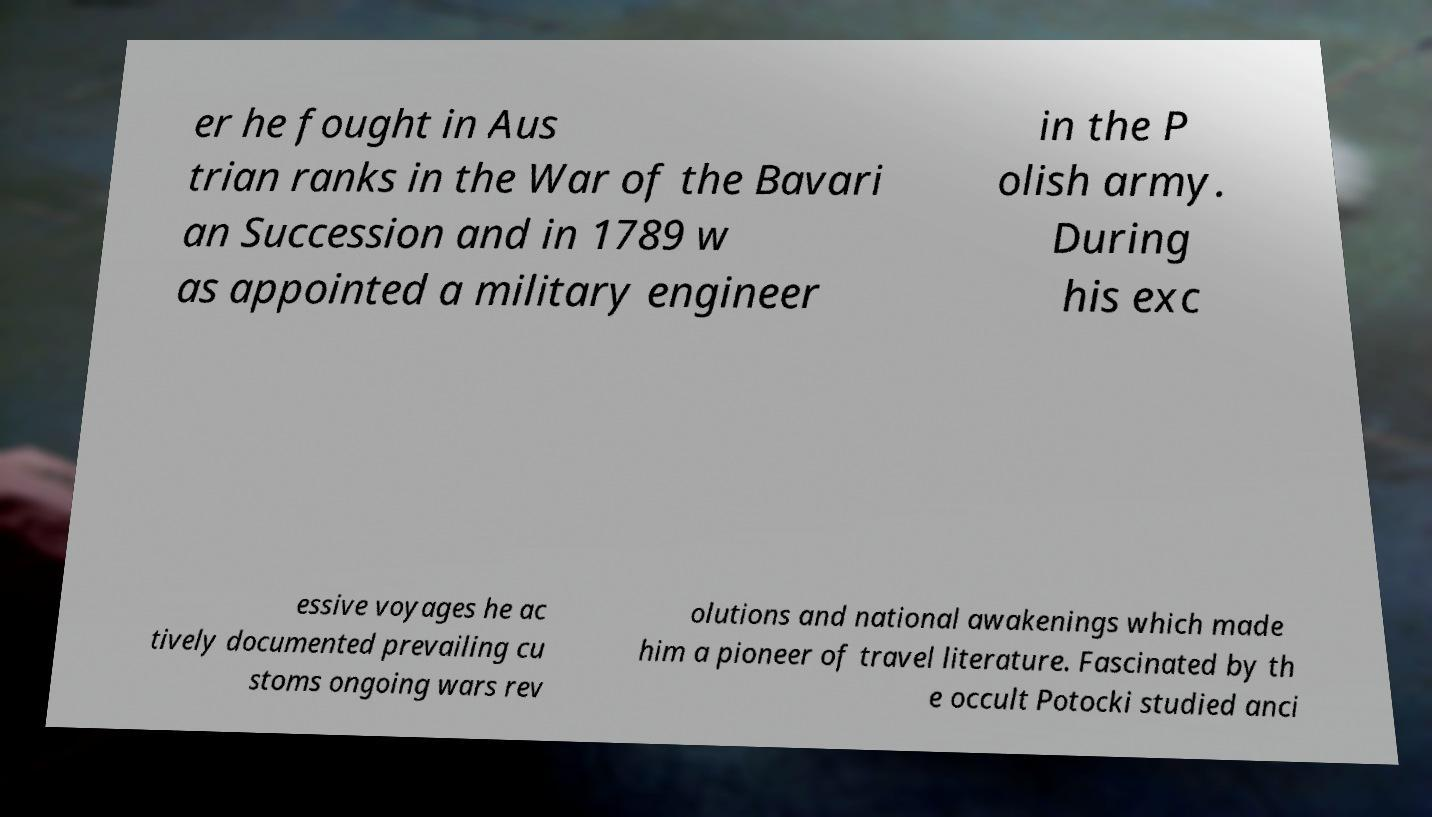For documentation purposes, I need the text within this image transcribed. Could you provide that? er he fought in Aus trian ranks in the War of the Bavari an Succession and in 1789 w as appointed a military engineer in the P olish army. During his exc essive voyages he ac tively documented prevailing cu stoms ongoing wars rev olutions and national awakenings which made him a pioneer of travel literature. Fascinated by th e occult Potocki studied anci 